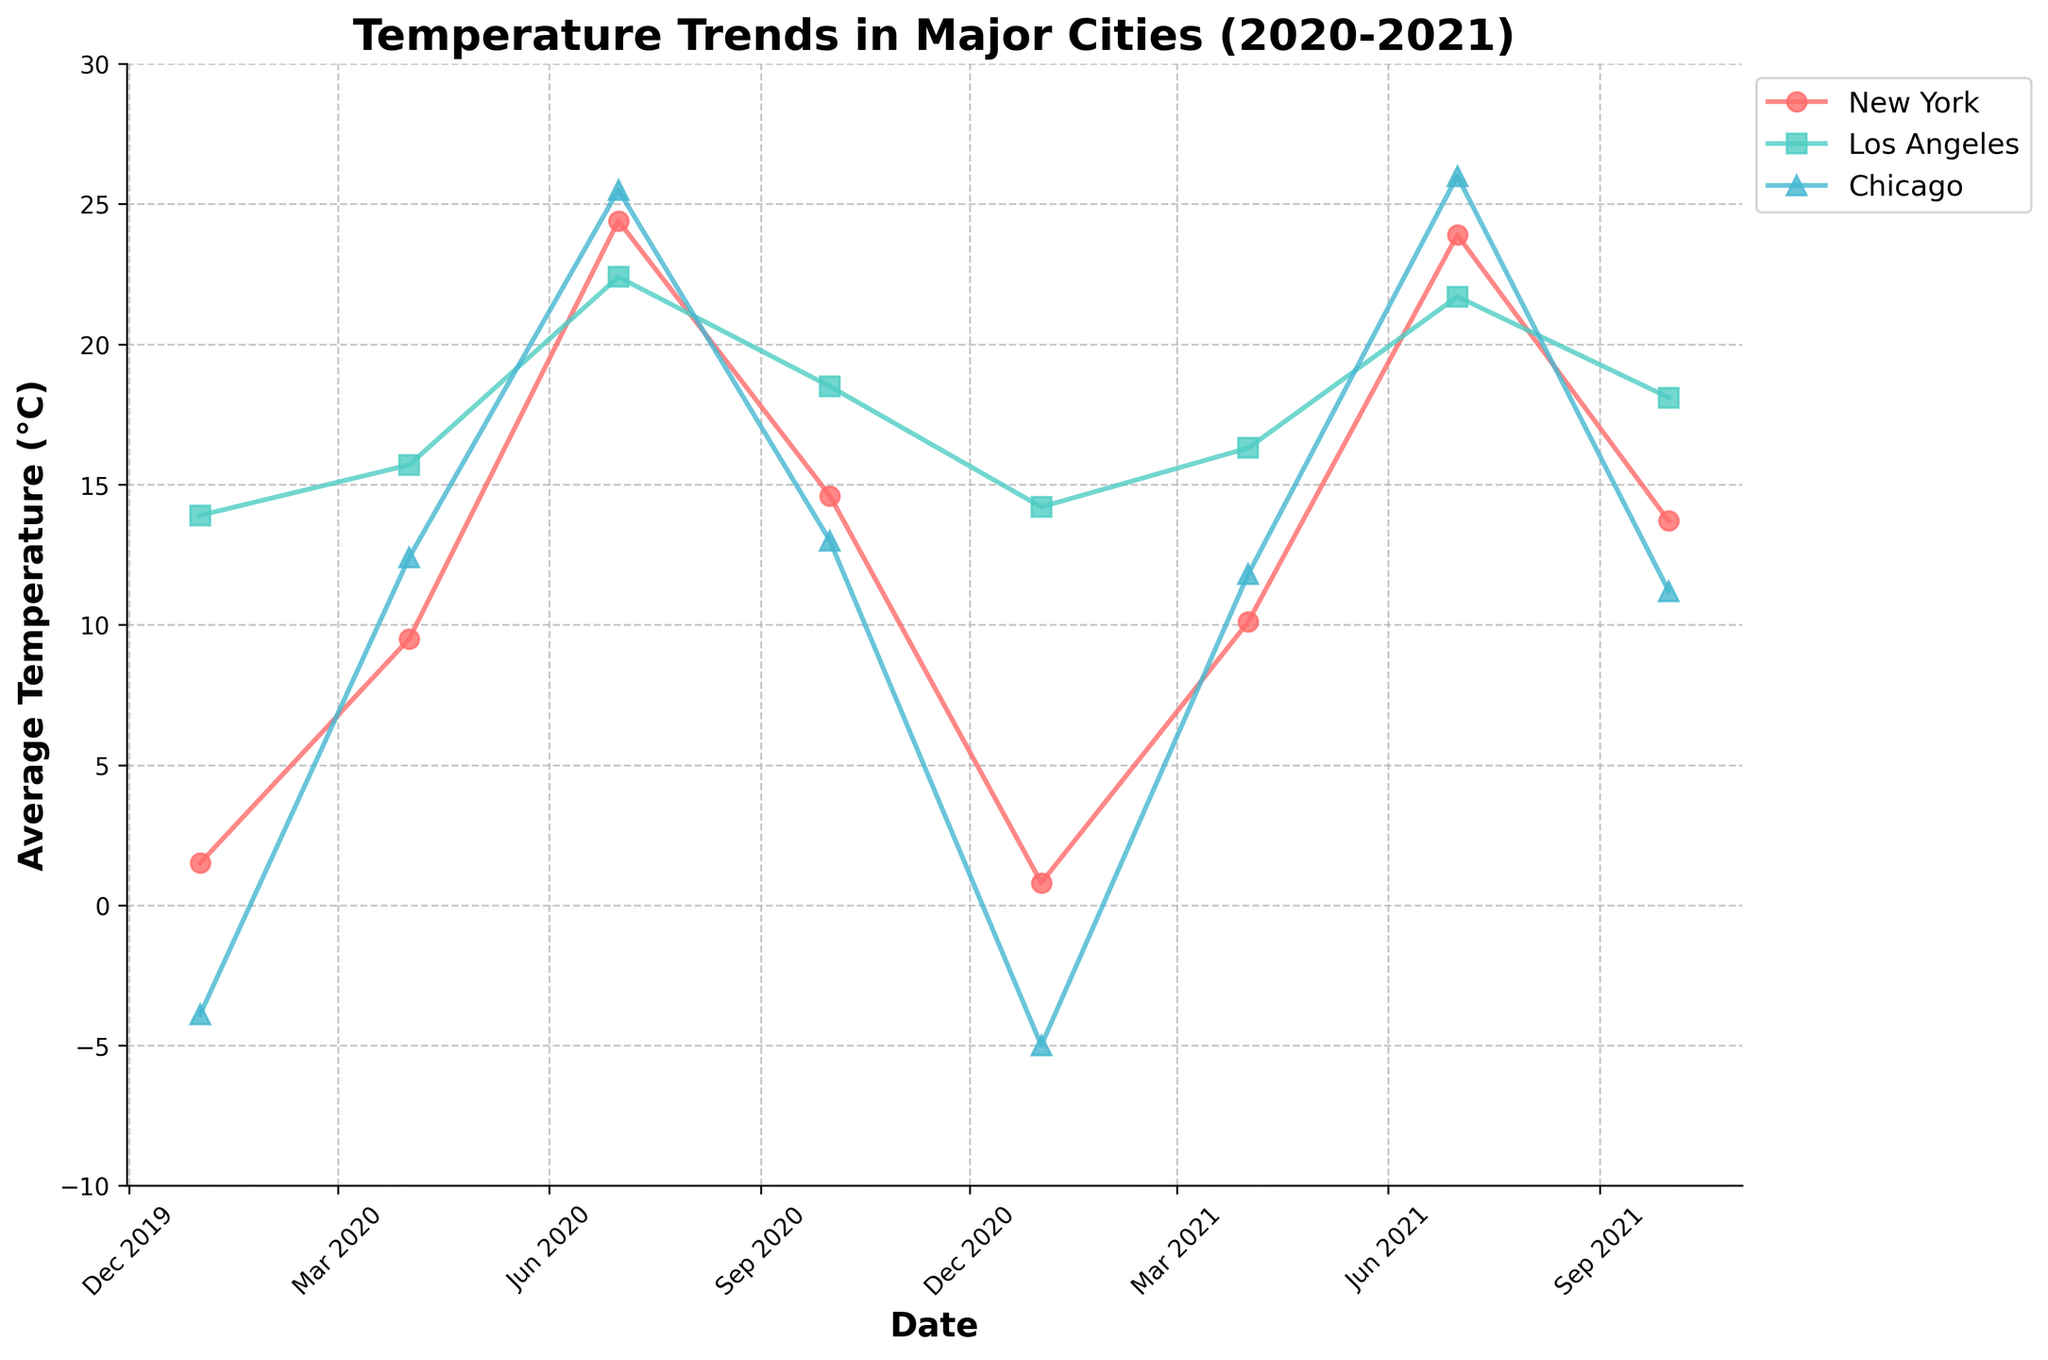What is the title of the figure? The title of the figure is prominently displayed at the top. It reads "Temperature Trends in Major Cities (2020-2021)."
Answer: Temperature Trends in Major Cities (2020-2021) Which city has the highest temperature in July 2020? By examining the data points for July 2020 across the cities, Chicago shows the highest temperature at 25.5°C.
Answer: Chicago Which city has the lowest temperature recorded in the given data? The lowest temperature can be found by identifying the lowest data point across all cities and dates. Chicago has the lowest temperature at -5.0°C in January 2021.
Answer: Chicago How does New York's average temperature change from January 2020 to January 2021? From January 2020 to January 2021, New York's temperature slightly decreases from 1.5°C to 0.8°C.
Answer: Decreases What is the average temperature of Los Angeles in the given data? Los Angeles temperatures in the time series are 13.9°C (Jan 2020), 15.7°C (Apr 2020), 22.4°C (Jul 2020), 18.5°C (Oct 2020), 14.2°C (Jan 2021), 16.3°C (Apr 2021), 21.7°C (Jul 2021), and 18.1°C (Oct 2021). Summing these and dividing by 8 gives the average: (13.9 + 15.7 + 22.4 + 18.5 + 14.2 + 16.3 + 21.7 + 18.1) / 8 = 17.6°C.
Answer: 17.6°C During which month and year does New York have the highest average temperature? By checking the data points for New York throughout the timeline, the highest average temperature for New York is in July 2020 at 24.4°C.
Answer: July 2020 Compare the temperature trends of New York and Los Angeles in April for 2020 and 2021 – which city witnessed a greater increase? For April: New York's temperatures change from 9.5°C (2020) to 10.1°C (2021), an increase of 0.6°C. Los Angeles' temperatures change from 15.7°C (2020) to 16.3°C (2021), an increase of 0.6°C. Both cities witnessed the same increase of 0.6°C.
Answer: Same increase Which city shows the smallest temperature difference between January and July 2020? Examining the temperature difference:
- New York: 24.4 - 1.5 = 22.9°C
- Los Angeles: 22.4 - 13.9 = 8.5°C
- Chicago: 25.5 - (-3.9) = 29.4°C
The smallest difference is seen in Los Angeles with a 8.5°C change.
Answer: Los Angeles What is the pattern of seasonal variation in Chicago's temperatures across the shown period? Chicago shows the typical seasonal variation with lower temperatures in January and October (winter and fall) and higher temperatures in April and July (spring and summer). Specifically:
- Winter (Jan): very cold (-3.9°C to -5.0°C)
- Spring (Apr): moderate warming (12.4°C to 11.8°C)
- Summer (Jul): warmest months (25.5°C to 26.0°C)
- Fall (Oct): cooling down (13.0°C to 11.2°C)
Answer: Seasonal variation with extreme winters and warm summers 